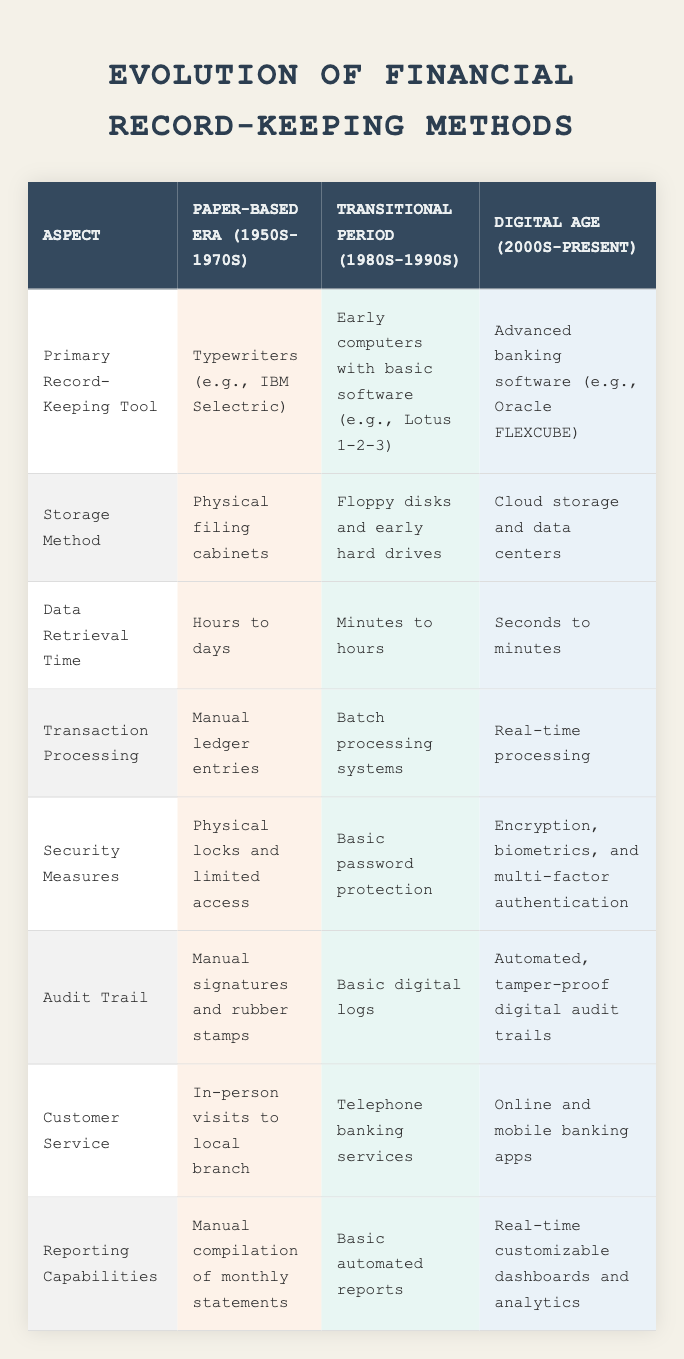What was the primary record-keeping tool used in the Paper-Based Era? The Paper-Based Era used typewriters, specifically examples like the IBM Selectric for record-keeping. Therefore, referring to the corresponding cell in the table provides the answer.
Answer: Typewriters (e.g., IBM Selectric) During which era was the transition from physical filing cabinets to cloud storage observed? The transition from physical filing cabinets to cloud storage occurred between the Transitional Period (1980s-1990s) and the Digital Age (2000s-Present). This can be gathered by comparing the storage methods in those two eras.
Answer: Transitional Period (1980s-1990s) What is the average time to retrieve data in the Digital Age? The data retrieval times for the Digital Age are listed as "Seconds to minutes." If we consider a rough estimate, it averages to around 1 minute (or 60 seconds). However, since the data provided is qualitative, we can summarize that retrieval is significantly quicker compared to previous eras.
Answer: Seconds to minutes Did security measures evolve from physical locks to advanced methods? Yes, the table indicates that physical locks and limited access characterized security measures in the Paper-Based Era, while the Digital Age has advanced to include encryption, biometrics, and multi-factor authentication. This is a clear evolution of security approaches.
Answer: Yes In which era did transaction processing primarily consist of manual ledger entries? According to the table, manual ledger entries were predominantly used during the Paper-Based Era (1950s-1970s) for transaction processing, as per the specific row for transaction processing.
Answer: Paper-Based Era (1950s-1970s) What are the differences in customer service methods from the Paper-Based Era to the Digital Age? The Paper-Based Era relied on in-person visits to local branches for customer service, while the Digital Age offers online and mobile banking apps for convenience. This shows a significant shift in how customer service is delivered.
Answer: Significant differences in service delivery methods How much quicker is data retrieval in the Digital Age compared to the Paper-Based Era? In the Paper-Based Era, data retrieval times range from hours to days, whereas in the Digital Age it is reduced to seconds to minutes. This represents a substantial decrease in retrieval time from potentially days to as little as seconds.
Answer: Substantially quicker Was the transition to real-time processing seen in the Digital Age? Yes, the table states that real-time processing became the standard during the Digital Age, indicating a significant upgrade from the batch processing systems of the Transitional Period.
Answer: Yes What is the primary method of reporting capabilities in the Transitional Period? The Transitional Period is characterized by basic automated reports. This can be found in the reporting capabilities section of the table, indicating how reporting evolved over time.
Answer: Basic automated reports 